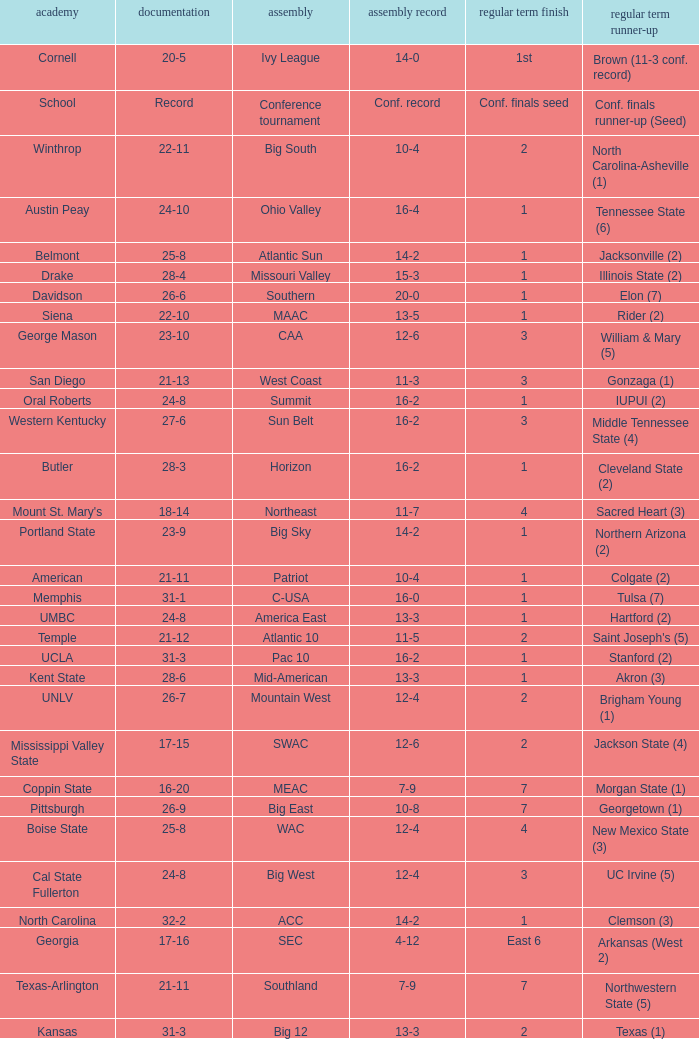Which qualifying schools were in the Patriot conference? American. 